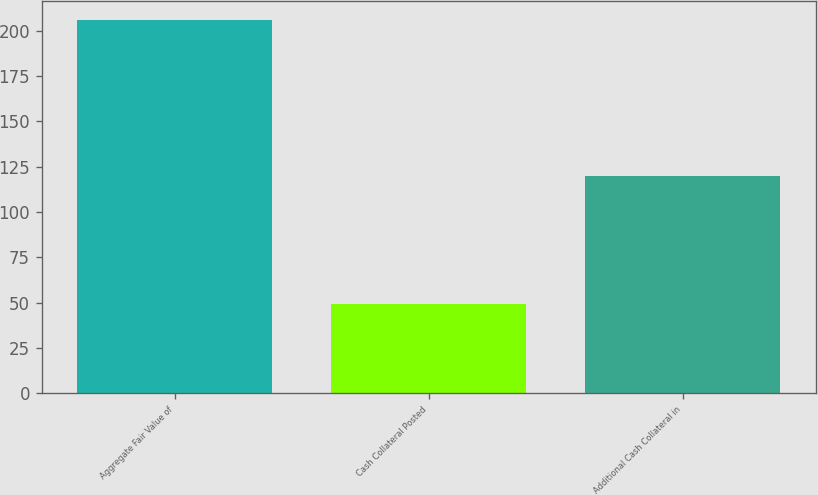Convert chart. <chart><loc_0><loc_0><loc_500><loc_500><bar_chart><fcel>Aggregate Fair Value of<fcel>Cash Collateral Posted<fcel>Additional Cash Collateral in<nl><fcel>206<fcel>49<fcel>120<nl></chart> 